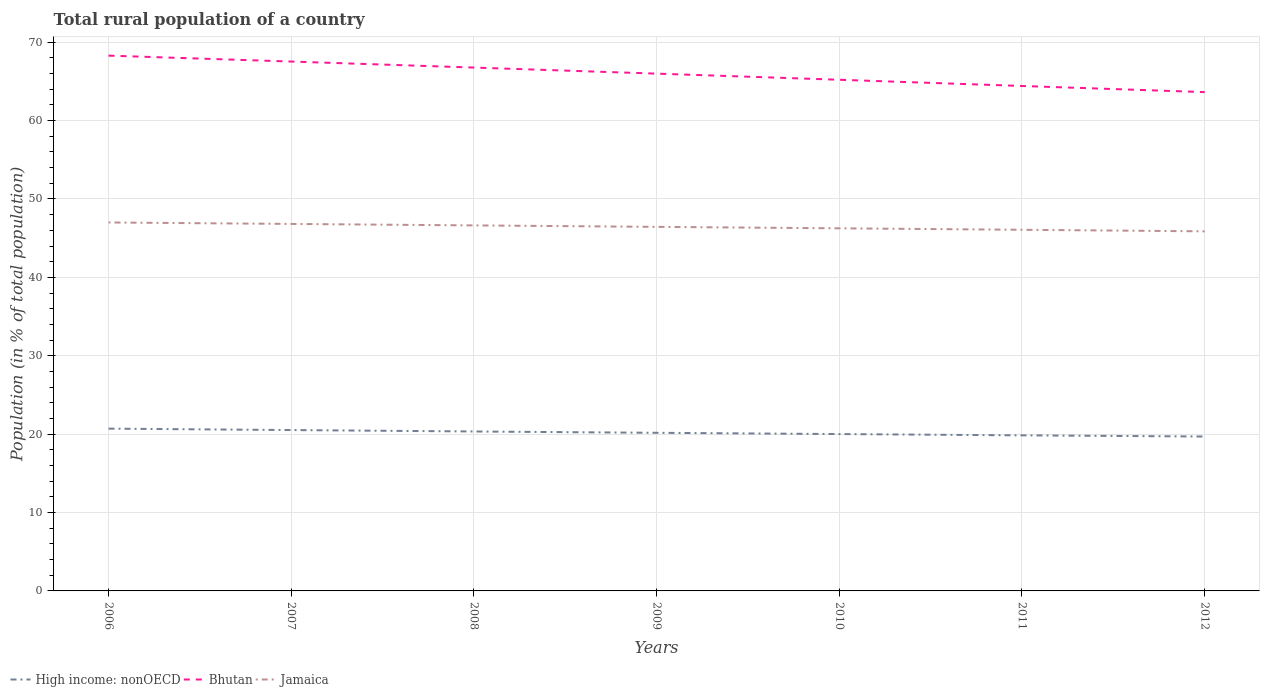How many different coloured lines are there?
Offer a terse response. 3. Across all years, what is the maximum rural population in Bhutan?
Provide a short and direct response. 63.63. What is the total rural population in Bhutan in the graph?
Your response must be concise. 4.66. What is the difference between the highest and the second highest rural population in Jamaica?
Keep it short and to the point. 1.13. What is the difference between the highest and the lowest rural population in Bhutan?
Keep it short and to the point. 4. What is the difference between two consecutive major ticks on the Y-axis?
Provide a succinct answer. 10. Does the graph contain grids?
Give a very brief answer. Yes. Where does the legend appear in the graph?
Ensure brevity in your answer.  Bottom left. How are the legend labels stacked?
Give a very brief answer. Horizontal. What is the title of the graph?
Ensure brevity in your answer.  Total rural population of a country. What is the label or title of the Y-axis?
Offer a terse response. Population (in % of total population). What is the Population (in % of total population) in High income: nonOECD in 2006?
Provide a succinct answer. 20.7. What is the Population (in % of total population) of Bhutan in 2006?
Offer a terse response. 68.29. What is the Population (in % of total population) of Jamaica in 2006?
Offer a very short reply. 47. What is the Population (in % of total population) of High income: nonOECD in 2007?
Your response must be concise. 20.52. What is the Population (in % of total population) in Bhutan in 2007?
Your answer should be very brief. 67.53. What is the Population (in % of total population) in Jamaica in 2007?
Provide a short and direct response. 46.82. What is the Population (in % of total population) of High income: nonOECD in 2008?
Provide a succinct answer. 20.34. What is the Population (in % of total population) in Bhutan in 2008?
Your answer should be very brief. 66.76. What is the Population (in % of total population) in Jamaica in 2008?
Provide a succinct answer. 46.63. What is the Population (in % of total population) in High income: nonOECD in 2009?
Make the answer very short. 20.17. What is the Population (in % of total population) of Bhutan in 2009?
Offer a terse response. 65.99. What is the Population (in % of total population) of Jamaica in 2009?
Provide a succinct answer. 46.44. What is the Population (in % of total population) of High income: nonOECD in 2010?
Provide a succinct answer. 20.01. What is the Population (in % of total population) in Bhutan in 2010?
Your answer should be compact. 65.21. What is the Population (in % of total population) in Jamaica in 2010?
Offer a very short reply. 46.26. What is the Population (in % of total population) in High income: nonOECD in 2011?
Your response must be concise. 19.85. What is the Population (in % of total population) of Bhutan in 2011?
Offer a very short reply. 64.42. What is the Population (in % of total population) in Jamaica in 2011?
Your answer should be very brief. 46.07. What is the Population (in % of total population) in High income: nonOECD in 2012?
Your answer should be very brief. 19.7. What is the Population (in % of total population) in Bhutan in 2012?
Ensure brevity in your answer.  63.63. What is the Population (in % of total population) in Jamaica in 2012?
Your response must be concise. 45.87. Across all years, what is the maximum Population (in % of total population) in High income: nonOECD?
Your response must be concise. 20.7. Across all years, what is the maximum Population (in % of total population) of Bhutan?
Your answer should be very brief. 68.29. Across all years, what is the maximum Population (in % of total population) of Jamaica?
Provide a succinct answer. 47. Across all years, what is the minimum Population (in % of total population) of High income: nonOECD?
Provide a short and direct response. 19.7. Across all years, what is the minimum Population (in % of total population) in Bhutan?
Provide a succinct answer. 63.63. Across all years, what is the minimum Population (in % of total population) of Jamaica?
Ensure brevity in your answer.  45.87. What is the total Population (in % of total population) in High income: nonOECD in the graph?
Make the answer very short. 141.29. What is the total Population (in % of total population) in Bhutan in the graph?
Give a very brief answer. 461.83. What is the total Population (in % of total population) in Jamaica in the graph?
Give a very brief answer. 325.09. What is the difference between the Population (in % of total population) of High income: nonOECD in 2006 and that in 2007?
Keep it short and to the point. 0.18. What is the difference between the Population (in % of total population) of Bhutan in 2006 and that in 2007?
Offer a very short reply. 0.76. What is the difference between the Population (in % of total population) in Jamaica in 2006 and that in 2007?
Your answer should be very brief. 0.19. What is the difference between the Population (in % of total population) in High income: nonOECD in 2006 and that in 2008?
Give a very brief answer. 0.36. What is the difference between the Population (in % of total population) of Bhutan in 2006 and that in 2008?
Your answer should be compact. 1.52. What is the difference between the Population (in % of total population) of Jamaica in 2006 and that in 2008?
Offer a terse response. 0.37. What is the difference between the Population (in % of total population) of High income: nonOECD in 2006 and that in 2009?
Ensure brevity in your answer.  0.53. What is the difference between the Population (in % of total population) in Bhutan in 2006 and that in 2009?
Ensure brevity in your answer.  2.3. What is the difference between the Population (in % of total population) of Jamaica in 2006 and that in 2009?
Give a very brief answer. 0.56. What is the difference between the Population (in % of total population) in High income: nonOECD in 2006 and that in 2010?
Make the answer very short. 0.69. What is the difference between the Population (in % of total population) in Bhutan in 2006 and that in 2010?
Provide a short and direct response. 3.08. What is the difference between the Population (in % of total population) in Jamaica in 2006 and that in 2010?
Ensure brevity in your answer.  0.74. What is the difference between the Population (in % of total population) of High income: nonOECD in 2006 and that in 2011?
Offer a very short reply. 0.86. What is the difference between the Population (in % of total population) in Bhutan in 2006 and that in 2011?
Your answer should be very brief. 3.87. What is the difference between the Population (in % of total population) in Jamaica in 2006 and that in 2011?
Make the answer very short. 0.93. What is the difference between the Population (in % of total population) of High income: nonOECD in 2006 and that in 2012?
Offer a terse response. 1.01. What is the difference between the Population (in % of total population) in Bhutan in 2006 and that in 2012?
Make the answer very short. 4.66. What is the difference between the Population (in % of total population) in Jamaica in 2006 and that in 2012?
Offer a very short reply. 1.13. What is the difference between the Population (in % of total population) in High income: nonOECD in 2007 and that in 2008?
Offer a terse response. 0.18. What is the difference between the Population (in % of total population) of Bhutan in 2007 and that in 2008?
Your response must be concise. 0.77. What is the difference between the Population (in % of total population) in Jamaica in 2007 and that in 2008?
Keep it short and to the point. 0.19. What is the difference between the Population (in % of total population) in High income: nonOECD in 2007 and that in 2009?
Provide a short and direct response. 0.35. What is the difference between the Population (in % of total population) of Bhutan in 2007 and that in 2009?
Offer a terse response. 1.54. What is the difference between the Population (in % of total population) in Jamaica in 2007 and that in 2009?
Your response must be concise. 0.37. What is the difference between the Population (in % of total population) in High income: nonOECD in 2007 and that in 2010?
Offer a very short reply. 0.51. What is the difference between the Population (in % of total population) of Bhutan in 2007 and that in 2010?
Offer a very short reply. 2.32. What is the difference between the Population (in % of total population) in Jamaica in 2007 and that in 2010?
Ensure brevity in your answer.  0.56. What is the difference between the Population (in % of total population) in High income: nonOECD in 2007 and that in 2011?
Your answer should be compact. 0.67. What is the difference between the Population (in % of total population) in Bhutan in 2007 and that in 2011?
Ensure brevity in your answer.  3.12. What is the difference between the Population (in % of total population) of Jamaica in 2007 and that in 2011?
Keep it short and to the point. 0.75. What is the difference between the Population (in % of total population) of High income: nonOECD in 2007 and that in 2012?
Your response must be concise. 0.82. What is the difference between the Population (in % of total population) of Bhutan in 2007 and that in 2012?
Offer a terse response. 3.9. What is the difference between the Population (in % of total population) of Jamaica in 2007 and that in 2012?
Provide a succinct answer. 0.94. What is the difference between the Population (in % of total population) of High income: nonOECD in 2008 and that in 2009?
Offer a terse response. 0.17. What is the difference between the Population (in % of total population) in Bhutan in 2008 and that in 2009?
Give a very brief answer. 0.77. What is the difference between the Population (in % of total population) of Jamaica in 2008 and that in 2009?
Keep it short and to the point. 0.19. What is the difference between the Population (in % of total population) of High income: nonOECD in 2008 and that in 2010?
Offer a terse response. 0.33. What is the difference between the Population (in % of total population) in Bhutan in 2008 and that in 2010?
Make the answer very short. 1.56. What is the difference between the Population (in % of total population) of Jamaica in 2008 and that in 2010?
Keep it short and to the point. 0.37. What is the difference between the Population (in % of total population) in High income: nonOECD in 2008 and that in 2011?
Give a very brief answer. 0.49. What is the difference between the Population (in % of total population) in Bhutan in 2008 and that in 2011?
Ensure brevity in your answer.  2.35. What is the difference between the Population (in % of total population) in Jamaica in 2008 and that in 2011?
Offer a terse response. 0.56. What is the difference between the Population (in % of total population) of High income: nonOECD in 2008 and that in 2012?
Your answer should be compact. 0.64. What is the difference between the Population (in % of total population) of Bhutan in 2008 and that in 2012?
Your response must be concise. 3.13. What is the difference between the Population (in % of total population) in Jamaica in 2008 and that in 2012?
Offer a very short reply. 0.76. What is the difference between the Population (in % of total population) in High income: nonOECD in 2009 and that in 2010?
Ensure brevity in your answer.  0.16. What is the difference between the Population (in % of total population) of Bhutan in 2009 and that in 2010?
Your answer should be very brief. 0.78. What is the difference between the Population (in % of total population) in Jamaica in 2009 and that in 2010?
Make the answer very short. 0.19. What is the difference between the Population (in % of total population) in High income: nonOECD in 2009 and that in 2011?
Your answer should be very brief. 0.32. What is the difference between the Population (in % of total population) of Bhutan in 2009 and that in 2011?
Keep it short and to the point. 1.57. What is the difference between the Population (in % of total population) of Jamaica in 2009 and that in 2011?
Offer a very short reply. 0.37. What is the difference between the Population (in % of total population) of High income: nonOECD in 2009 and that in 2012?
Your answer should be compact. 0.47. What is the difference between the Population (in % of total population) in Bhutan in 2009 and that in 2012?
Keep it short and to the point. 2.36. What is the difference between the Population (in % of total population) in Jamaica in 2009 and that in 2012?
Offer a terse response. 0.57. What is the difference between the Population (in % of total population) in High income: nonOECD in 2010 and that in 2011?
Your answer should be compact. 0.16. What is the difference between the Population (in % of total population) in Bhutan in 2010 and that in 2011?
Your response must be concise. 0.79. What is the difference between the Population (in % of total population) in Jamaica in 2010 and that in 2011?
Provide a short and direct response. 0.19. What is the difference between the Population (in % of total population) in High income: nonOECD in 2010 and that in 2012?
Offer a very short reply. 0.31. What is the difference between the Population (in % of total population) of Bhutan in 2010 and that in 2012?
Provide a short and direct response. 1.57. What is the difference between the Population (in % of total population) of Jamaica in 2010 and that in 2012?
Keep it short and to the point. 0.38. What is the difference between the Population (in % of total population) in High income: nonOECD in 2011 and that in 2012?
Your response must be concise. 0.15. What is the difference between the Population (in % of total population) in Bhutan in 2011 and that in 2012?
Provide a short and direct response. 0.78. What is the difference between the Population (in % of total population) of Jamaica in 2011 and that in 2012?
Your answer should be compact. 0.2. What is the difference between the Population (in % of total population) of High income: nonOECD in 2006 and the Population (in % of total population) of Bhutan in 2007?
Provide a succinct answer. -46.83. What is the difference between the Population (in % of total population) in High income: nonOECD in 2006 and the Population (in % of total population) in Jamaica in 2007?
Offer a very short reply. -26.11. What is the difference between the Population (in % of total population) in Bhutan in 2006 and the Population (in % of total population) in Jamaica in 2007?
Your response must be concise. 21.47. What is the difference between the Population (in % of total population) of High income: nonOECD in 2006 and the Population (in % of total population) of Bhutan in 2008?
Offer a very short reply. -46.06. What is the difference between the Population (in % of total population) of High income: nonOECD in 2006 and the Population (in % of total population) of Jamaica in 2008?
Provide a short and direct response. -25.93. What is the difference between the Population (in % of total population) in Bhutan in 2006 and the Population (in % of total population) in Jamaica in 2008?
Give a very brief answer. 21.66. What is the difference between the Population (in % of total population) in High income: nonOECD in 2006 and the Population (in % of total population) in Bhutan in 2009?
Ensure brevity in your answer.  -45.29. What is the difference between the Population (in % of total population) of High income: nonOECD in 2006 and the Population (in % of total population) of Jamaica in 2009?
Provide a succinct answer. -25.74. What is the difference between the Population (in % of total population) of Bhutan in 2006 and the Population (in % of total population) of Jamaica in 2009?
Your response must be concise. 21.84. What is the difference between the Population (in % of total population) of High income: nonOECD in 2006 and the Population (in % of total population) of Bhutan in 2010?
Give a very brief answer. -44.5. What is the difference between the Population (in % of total population) of High income: nonOECD in 2006 and the Population (in % of total population) of Jamaica in 2010?
Offer a very short reply. -25.55. What is the difference between the Population (in % of total population) in Bhutan in 2006 and the Population (in % of total population) in Jamaica in 2010?
Provide a succinct answer. 22.03. What is the difference between the Population (in % of total population) in High income: nonOECD in 2006 and the Population (in % of total population) in Bhutan in 2011?
Ensure brevity in your answer.  -43.71. What is the difference between the Population (in % of total population) of High income: nonOECD in 2006 and the Population (in % of total population) of Jamaica in 2011?
Provide a short and direct response. -25.37. What is the difference between the Population (in % of total population) in Bhutan in 2006 and the Population (in % of total population) in Jamaica in 2011?
Make the answer very short. 22.22. What is the difference between the Population (in % of total population) in High income: nonOECD in 2006 and the Population (in % of total population) in Bhutan in 2012?
Your answer should be compact. -42.93. What is the difference between the Population (in % of total population) of High income: nonOECD in 2006 and the Population (in % of total population) of Jamaica in 2012?
Ensure brevity in your answer.  -25.17. What is the difference between the Population (in % of total population) in Bhutan in 2006 and the Population (in % of total population) in Jamaica in 2012?
Offer a very short reply. 22.41. What is the difference between the Population (in % of total population) in High income: nonOECD in 2007 and the Population (in % of total population) in Bhutan in 2008?
Provide a succinct answer. -46.24. What is the difference between the Population (in % of total population) in High income: nonOECD in 2007 and the Population (in % of total population) in Jamaica in 2008?
Your answer should be compact. -26.11. What is the difference between the Population (in % of total population) in Bhutan in 2007 and the Population (in % of total population) in Jamaica in 2008?
Your answer should be very brief. 20.9. What is the difference between the Population (in % of total population) in High income: nonOECD in 2007 and the Population (in % of total population) in Bhutan in 2009?
Your answer should be compact. -45.47. What is the difference between the Population (in % of total population) of High income: nonOECD in 2007 and the Population (in % of total population) of Jamaica in 2009?
Your answer should be compact. -25.92. What is the difference between the Population (in % of total population) of Bhutan in 2007 and the Population (in % of total population) of Jamaica in 2009?
Your response must be concise. 21.09. What is the difference between the Population (in % of total population) of High income: nonOECD in 2007 and the Population (in % of total population) of Bhutan in 2010?
Provide a short and direct response. -44.69. What is the difference between the Population (in % of total population) of High income: nonOECD in 2007 and the Population (in % of total population) of Jamaica in 2010?
Give a very brief answer. -25.74. What is the difference between the Population (in % of total population) in Bhutan in 2007 and the Population (in % of total population) in Jamaica in 2010?
Ensure brevity in your answer.  21.27. What is the difference between the Population (in % of total population) of High income: nonOECD in 2007 and the Population (in % of total population) of Bhutan in 2011?
Keep it short and to the point. -43.89. What is the difference between the Population (in % of total population) in High income: nonOECD in 2007 and the Population (in % of total population) in Jamaica in 2011?
Give a very brief answer. -25.55. What is the difference between the Population (in % of total population) in Bhutan in 2007 and the Population (in % of total population) in Jamaica in 2011?
Ensure brevity in your answer.  21.46. What is the difference between the Population (in % of total population) of High income: nonOECD in 2007 and the Population (in % of total population) of Bhutan in 2012?
Your answer should be very brief. -43.11. What is the difference between the Population (in % of total population) of High income: nonOECD in 2007 and the Population (in % of total population) of Jamaica in 2012?
Offer a terse response. -25.35. What is the difference between the Population (in % of total population) in Bhutan in 2007 and the Population (in % of total population) in Jamaica in 2012?
Your response must be concise. 21.66. What is the difference between the Population (in % of total population) of High income: nonOECD in 2008 and the Population (in % of total population) of Bhutan in 2009?
Offer a very short reply. -45.65. What is the difference between the Population (in % of total population) of High income: nonOECD in 2008 and the Population (in % of total population) of Jamaica in 2009?
Provide a succinct answer. -26.1. What is the difference between the Population (in % of total population) of Bhutan in 2008 and the Population (in % of total population) of Jamaica in 2009?
Your answer should be very brief. 20.32. What is the difference between the Population (in % of total population) in High income: nonOECD in 2008 and the Population (in % of total population) in Bhutan in 2010?
Keep it short and to the point. -44.87. What is the difference between the Population (in % of total population) of High income: nonOECD in 2008 and the Population (in % of total population) of Jamaica in 2010?
Keep it short and to the point. -25.92. What is the difference between the Population (in % of total population) of Bhutan in 2008 and the Population (in % of total population) of Jamaica in 2010?
Give a very brief answer. 20.51. What is the difference between the Population (in % of total population) of High income: nonOECD in 2008 and the Population (in % of total population) of Bhutan in 2011?
Offer a terse response. -44.08. What is the difference between the Population (in % of total population) in High income: nonOECD in 2008 and the Population (in % of total population) in Jamaica in 2011?
Your response must be concise. -25.73. What is the difference between the Population (in % of total population) in Bhutan in 2008 and the Population (in % of total population) in Jamaica in 2011?
Provide a short and direct response. 20.69. What is the difference between the Population (in % of total population) of High income: nonOECD in 2008 and the Population (in % of total population) of Bhutan in 2012?
Give a very brief answer. -43.29. What is the difference between the Population (in % of total population) of High income: nonOECD in 2008 and the Population (in % of total population) of Jamaica in 2012?
Your answer should be very brief. -25.53. What is the difference between the Population (in % of total population) in Bhutan in 2008 and the Population (in % of total population) in Jamaica in 2012?
Ensure brevity in your answer.  20.89. What is the difference between the Population (in % of total population) of High income: nonOECD in 2009 and the Population (in % of total population) of Bhutan in 2010?
Offer a terse response. -45.04. What is the difference between the Population (in % of total population) of High income: nonOECD in 2009 and the Population (in % of total population) of Jamaica in 2010?
Your answer should be compact. -26.09. What is the difference between the Population (in % of total population) in Bhutan in 2009 and the Population (in % of total population) in Jamaica in 2010?
Your response must be concise. 19.73. What is the difference between the Population (in % of total population) in High income: nonOECD in 2009 and the Population (in % of total population) in Bhutan in 2011?
Offer a terse response. -44.24. What is the difference between the Population (in % of total population) in High income: nonOECD in 2009 and the Population (in % of total population) in Jamaica in 2011?
Give a very brief answer. -25.9. What is the difference between the Population (in % of total population) of Bhutan in 2009 and the Population (in % of total population) of Jamaica in 2011?
Give a very brief answer. 19.92. What is the difference between the Population (in % of total population) of High income: nonOECD in 2009 and the Population (in % of total population) of Bhutan in 2012?
Keep it short and to the point. -43.46. What is the difference between the Population (in % of total population) in High income: nonOECD in 2009 and the Population (in % of total population) in Jamaica in 2012?
Keep it short and to the point. -25.7. What is the difference between the Population (in % of total population) of Bhutan in 2009 and the Population (in % of total population) of Jamaica in 2012?
Your answer should be very brief. 20.12. What is the difference between the Population (in % of total population) in High income: nonOECD in 2010 and the Population (in % of total population) in Bhutan in 2011?
Your response must be concise. -44.4. What is the difference between the Population (in % of total population) in High income: nonOECD in 2010 and the Population (in % of total population) in Jamaica in 2011?
Provide a succinct answer. -26.06. What is the difference between the Population (in % of total population) of Bhutan in 2010 and the Population (in % of total population) of Jamaica in 2011?
Provide a short and direct response. 19.14. What is the difference between the Population (in % of total population) of High income: nonOECD in 2010 and the Population (in % of total population) of Bhutan in 2012?
Offer a very short reply. -43.62. What is the difference between the Population (in % of total population) in High income: nonOECD in 2010 and the Population (in % of total population) in Jamaica in 2012?
Keep it short and to the point. -25.86. What is the difference between the Population (in % of total population) of Bhutan in 2010 and the Population (in % of total population) of Jamaica in 2012?
Keep it short and to the point. 19.33. What is the difference between the Population (in % of total population) in High income: nonOECD in 2011 and the Population (in % of total population) in Bhutan in 2012?
Provide a short and direct response. -43.78. What is the difference between the Population (in % of total population) in High income: nonOECD in 2011 and the Population (in % of total population) in Jamaica in 2012?
Make the answer very short. -26.03. What is the difference between the Population (in % of total population) in Bhutan in 2011 and the Population (in % of total population) in Jamaica in 2012?
Your response must be concise. 18.54. What is the average Population (in % of total population) in High income: nonOECD per year?
Your answer should be very brief. 20.18. What is the average Population (in % of total population) in Bhutan per year?
Your response must be concise. 65.98. What is the average Population (in % of total population) in Jamaica per year?
Give a very brief answer. 46.44. In the year 2006, what is the difference between the Population (in % of total population) in High income: nonOECD and Population (in % of total population) in Bhutan?
Your answer should be compact. -47.59. In the year 2006, what is the difference between the Population (in % of total population) in High income: nonOECD and Population (in % of total population) in Jamaica?
Ensure brevity in your answer.  -26.3. In the year 2006, what is the difference between the Population (in % of total population) of Bhutan and Population (in % of total population) of Jamaica?
Your response must be concise. 21.29. In the year 2007, what is the difference between the Population (in % of total population) in High income: nonOECD and Population (in % of total population) in Bhutan?
Keep it short and to the point. -47.01. In the year 2007, what is the difference between the Population (in % of total population) of High income: nonOECD and Population (in % of total population) of Jamaica?
Keep it short and to the point. -26.29. In the year 2007, what is the difference between the Population (in % of total population) in Bhutan and Population (in % of total population) in Jamaica?
Give a very brief answer. 20.71. In the year 2008, what is the difference between the Population (in % of total population) of High income: nonOECD and Population (in % of total population) of Bhutan?
Provide a short and direct response. -46.42. In the year 2008, what is the difference between the Population (in % of total population) in High income: nonOECD and Population (in % of total population) in Jamaica?
Keep it short and to the point. -26.29. In the year 2008, what is the difference between the Population (in % of total population) in Bhutan and Population (in % of total population) in Jamaica?
Give a very brief answer. 20.14. In the year 2009, what is the difference between the Population (in % of total population) of High income: nonOECD and Population (in % of total population) of Bhutan?
Provide a succinct answer. -45.82. In the year 2009, what is the difference between the Population (in % of total population) in High income: nonOECD and Population (in % of total population) in Jamaica?
Offer a terse response. -26.27. In the year 2009, what is the difference between the Population (in % of total population) in Bhutan and Population (in % of total population) in Jamaica?
Offer a terse response. 19.55. In the year 2010, what is the difference between the Population (in % of total population) of High income: nonOECD and Population (in % of total population) of Bhutan?
Ensure brevity in your answer.  -45.2. In the year 2010, what is the difference between the Population (in % of total population) in High income: nonOECD and Population (in % of total population) in Jamaica?
Ensure brevity in your answer.  -26.25. In the year 2010, what is the difference between the Population (in % of total population) of Bhutan and Population (in % of total population) of Jamaica?
Your answer should be very brief. 18.95. In the year 2011, what is the difference between the Population (in % of total population) in High income: nonOECD and Population (in % of total population) in Bhutan?
Make the answer very short. -44.57. In the year 2011, what is the difference between the Population (in % of total population) of High income: nonOECD and Population (in % of total population) of Jamaica?
Your answer should be very brief. -26.22. In the year 2011, what is the difference between the Population (in % of total population) of Bhutan and Population (in % of total population) of Jamaica?
Your answer should be very brief. 18.34. In the year 2012, what is the difference between the Population (in % of total population) of High income: nonOECD and Population (in % of total population) of Bhutan?
Ensure brevity in your answer.  -43.94. In the year 2012, what is the difference between the Population (in % of total population) of High income: nonOECD and Population (in % of total population) of Jamaica?
Give a very brief answer. -26.18. In the year 2012, what is the difference between the Population (in % of total population) of Bhutan and Population (in % of total population) of Jamaica?
Ensure brevity in your answer.  17.76. What is the ratio of the Population (in % of total population) of High income: nonOECD in 2006 to that in 2007?
Make the answer very short. 1.01. What is the ratio of the Population (in % of total population) of Bhutan in 2006 to that in 2007?
Offer a terse response. 1.01. What is the ratio of the Population (in % of total population) of High income: nonOECD in 2006 to that in 2008?
Your answer should be compact. 1.02. What is the ratio of the Population (in % of total population) of Bhutan in 2006 to that in 2008?
Provide a succinct answer. 1.02. What is the ratio of the Population (in % of total population) of Jamaica in 2006 to that in 2008?
Keep it short and to the point. 1.01. What is the ratio of the Population (in % of total population) of High income: nonOECD in 2006 to that in 2009?
Make the answer very short. 1.03. What is the ratio of the Population (in % of total population) of Bhutan in 2006 to that in 2009?
Your response must be concise. 1.03. What is the ratio of the Population (in % of total population) of High income: nonOECD in 2006 to that in 2010?
Provide a short and direct response. 1.03. What is the ratio of the Population (in % of total population) of Bhutan in 2006 to that in 2010?
Offer a terse response. 1.05. What is the ratio of the Population (in % of total population) in Jamaica in 2006 to that in 2010?
Ensure brevity in your answer.  1.02. What is the ratio of the Population (in % of total population) of High income: nonOECD in 2006 to that in 2011?
Give a very brief answer. 1.04. What is the ratio of the Population (in % of total population) in Bhutan in 2006 to that in 2011?
Ensure brevity in your answer.  1.06. What is the ratio of the Population (in % of total population) of Jamaica in 2006 to that in 2011?
Make the answer very short. 1.02. What is the ratio of the Population (in % of total population) in High income: nonOECD in 2006 to that in 2012?
Keep it short and to the point. 1.05. What is the ratio of the Population (in % of total population) of Bhutan in 2006 to that in 2012?
Offer a very short reply. 1.07. What is the ratio of the Population (in % of total population) in Jamaica in 2006 to that in 2012?
Your answer should be very brief. 1.02. What is the ratio of the Population (in % of total population) of Bhutan in 2007 to that in 2008?
Provide a short and direct response. 1.01. What is the ratio of the Population (in % of total population) of High income: nonOECD in 2007 to that in 2009?
Your response must be concise. 1.02. What is the ratio of the Population (in % of total population) in Bhutan in 2007 to that in 2009?
Your answer should be very brief. 1.02. What is the ratio of the Population (in % of total population) in High income: nonOECD in 2007 to that in 2010?
Your response must be concise. 1.03. What is the ratio of the Population (in % of total population) in Bhutan in 2007 to that in 2010?
Give a very brief answer. 1.04. What is the ratio of the Population (in % of total population) in Jamaica in 2007 to that in 2010?
Make the answer very short. 1.01. What is the ratio of the Population (in % of total population) in High income: nonOECD in 2007 to that in 2011?
Your response must be concise. 1.03. What is the ratio of the Population (in % of total population) of Bhutan in 2007 to that in 2011?
Give a very brief answer. 1.05. What is the ratio of the Population (in % of total population) in Jamaica in 2007 to that in 2011?
Your answer should be very brief. 1.02. What is the ratio of the Population (in % of total population) in High income: nonOECD in 2007 to that in 2012?
Make the answer very short. 1.04. What is the ratio of the Population (in % of total population) in Bhutan in 2007 to that in 2012?
Ensure brevity in your answer.  1.06. What is the ratio of the Population (in % of total population) of Jamaica in 2007 to that in 2012?
Provide a succinct answer. 1.02. What is the ratio of the Population (in % of total population) in High income: nonOECD in 2008 to that in 2009?
Your response must be concise. 1.01. What is the ratio of the Population (in % of total population) in Bhutan in 2008 to that in 2009?
Offer a very short reply. 1.01. What is the ratio of the Population (in % of total population) of Jamaica in 2008 to that in 2009?
Make the answer very short. 1. What is the ratio of the Population (in % of total population) of High income: nonOECD in 2008 to that in 2010?
Your response must be concise. 1.02. What is the ratio of the Population (in % of total population) of Bhutan in 2008 to that in 2010?
Give a very brief answer. 1.02. What is the ratio of the Population (in % of total population) of Jamaica in 2008 to that in 2010?
Provide a short and direct response. 1.01. What is the ratio of the Population (in % of total population) of High income: nonOECD in 2008 to that in 2011?
Provide a succinct answer. 1.02. What is the ratio of the Population (in % of total population) in Bhutan in 2008 to that in 2011?
Offer a very short reply. 1.04. What is the ratio of the Population (in % of total population) in Jamaica in 2008 to that in 2011?
Keep it short and to the point. 1.01. What is the ratio of the Population (in % of total population) of High income: nonOECD in 2008 to that in 2012?
Provide a succinct answer. 1.03. What is the ratio of the Population (in % of total population) of Bhutan in 2008 to that in 2012?
Offer a very short reply. 1.05. What is the ratio of the Population (in % of total population) of Jamaica in 2008 to that in 2012?
Your answer should be very brief. 1.02. What is the ratio of the Population (in % of total population) of High income: nonOECD in 2009 to that in 2010?
Offer a terse response. 1.01. What is the ratio of the Population (in % of total population) in Jamaica in 2009 to that in 2010?
Your response must be concise. 1. What is the ratio of the Population (in % of total population) of High income: nonOECD in 2009 to that in 2011?
Give a very brief answer. 1.02. What is the ratio of the Population (in % of total population) of Bhutan in 2009 to that in 2011?
Offer a terse response. 1.02. What is the ratio of the Population (in % of total population) in Jamaica in 2009 to that in 2011?
Give a very brief answer. 1.01. What is the ratio of the Population (in % of total population) in High income: nonOECD in 2009 to that in 2012?
Keep it short and to the point. 1.02. What is the ratio of the Population (in % of total population) of Bhutan in 2009 to that in 2012?
Offer a terse response. 1.04. What is the ratio of the Population (in % of total population) in Jamaica in 2009 to that in 2012?
Keep it short and to the point. 1.01. What is the ratio of the Population (in % of total population) of High income: nonOECD in 2010 to that in 2011?
Make the answer very short. 1.01. What is the ratio of the Population (in % of total population) in Bhutan in 2010 to that in 2011?
Offer a very short reply. 1.01. What is the ratio of the Population (in % of total population) of High income: nonOECD in 2010 to that in 2012?
Keep it short and to the point. 1.02. What is the ratio of the Population (in % of total population) of Bhutan in 2010 to that in 2012?
Provide a succinct answer. 1.02. What is the ratio of the Population (in % of total population) of Jamaica in 2010 to that in 2012?
Your answer should be very brief. 1.01. What is the ratio of the Population (in % of total population) in High income: nonOECD in 2011 to that in 2012?
Offer a very short reply. 1.01. What is the ratio of the Population (in % of total population) in Bhutan in 2011 to that in 2012?
Offer a terse response. 1.01. What is the difference between the highest and the second highest Population (in % of total population) in High income: nonOECD?
Provide a succinct answer. 0.18. What is the difference between the highest and the second highest Population (in % of total population) in Bhutan?
Your answer should be very brief. 0.76. What is the difference between the highest and the second highest Population (in % of total population) of Jamaica?
Make the answer very short. 0.19. What is the difference between the highest and the lowest Population (in % of total population) in High income: nonOECD?
Your answer should be compact. 1.01. What is the difference between the highest and the lowest Population (in % of total population) in Bhutan?
Your answer should be very brief. 4.66. What is the difference between the highest and the lowest Population (in % of total population) in Jamaica?
Make the answer very short. 1.13. 